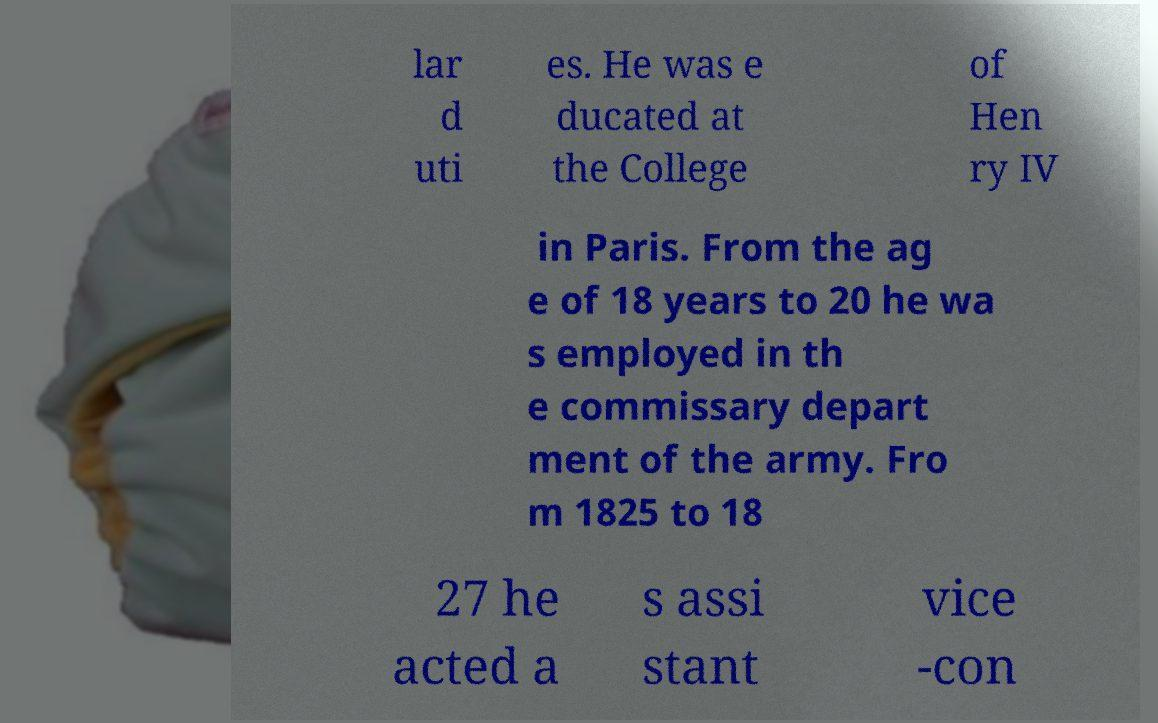What messages or text are displayed in this image? I need them in a readable, typed format. lar d uti es. He was e ducated at the College of Hen ry IV in Paris. From the ag e of 18 years to 20 he wa s employed in th e commissary depart ment of the army. Fro m 1825 to 18 27 he acted a s assi stant vice -con 